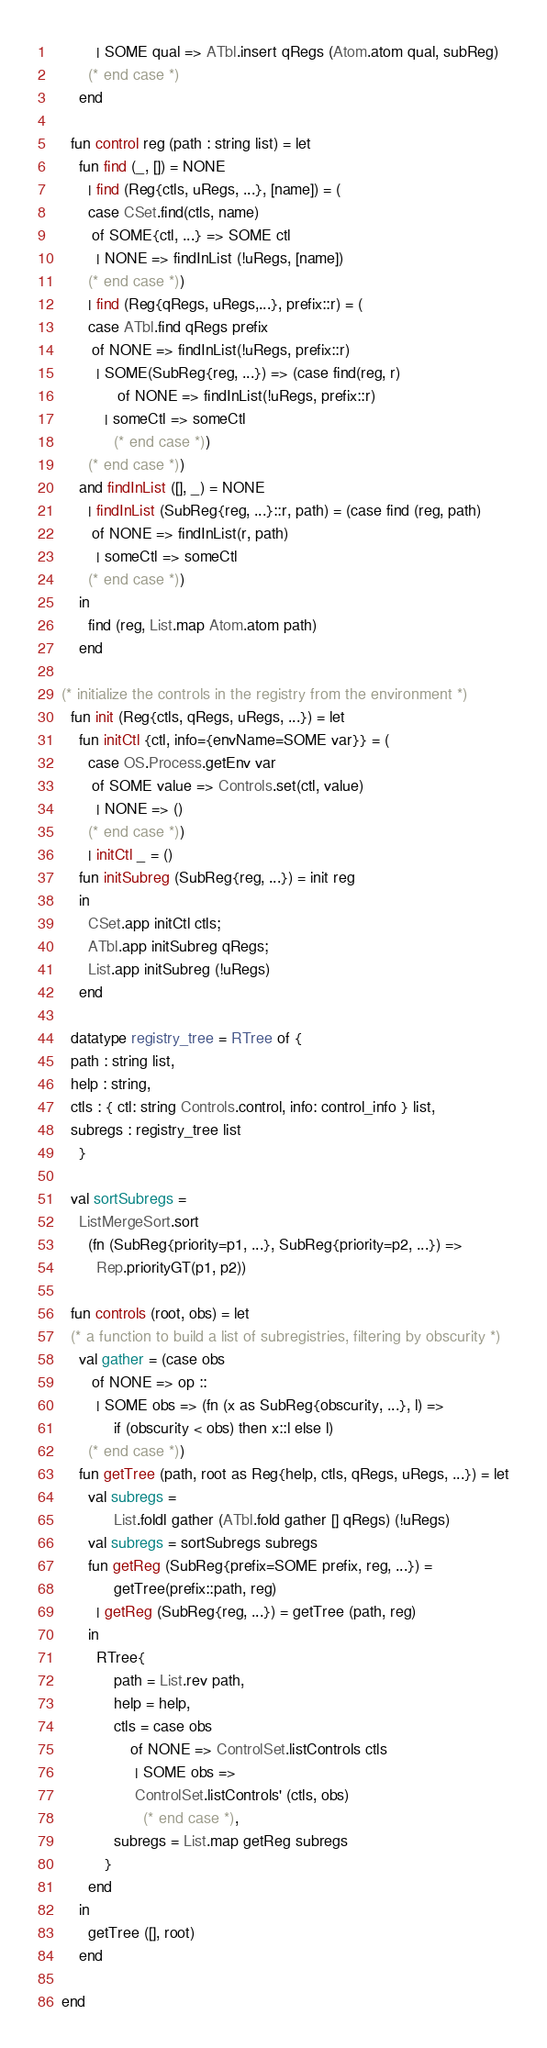<code> <loc_0><loc_0><loc_500><loc_500><_SML_>	      | SOME qual => ATbl.insert qRegs (Atom.atom qual, subReg)
	    (* end case *)
	  end

    fun control reg (path : string list) = let
	  fun find (_, []) = NONE
	    | find (Reg{ctls, uRegs, ...}, [name]) = (
		case CSet.find(ctls, name)
		 of SOME{ctl, ...} => SOME ctl
		  | NONE => findInList (!uRegs, [name])
		(* end case *))
	    | find (Reg{qRegs, uRegs,...}, prefix::r) = (
		case ATbl.find qRegs prefix
		 of NONE => findInList(!uRegs, prefix::r)
		  | SOME(SubReg{reg, ...}) => (case find(reg, r)
		       of NONE => findInList(!uRegs, prefix::r)
			| someCtl => someCtl
		      (* end case *))
		(* end case *))
	  and findInList ([], _) = NONE
	    | findInList (SubReg{reg, ...}::r, path) = (case find (reg, path)
		 of NONE => findInList(r, path)
		  | someCtl => someCtl
		(* end case *))
	  in
	    find (reg, List.map Atom.atom path)
	  end

  (* initialize the controls in the registry from the environment *)
    fun init (Reg{ctls, qRegs, uRegs, ...}) = let
	  fun initCtl {ctl, info={envName=SOME var}} = (
		case OS.Process.getEnv var
		 of SOME value => Controls.set(ctl, value)
		  | NONE => ()
		(* end case *))
	    | initCtl _ = ()
	  fun initSubreg (SubReg{reg, ...}) = init reg
	  in
	    CSet.app initCtl ctls;
	    ATbl.app initSubreg qRegs;
	    List.app initSubreg (!uRegs)
	  end

    datatype registry_tree = RTree of {
	path : string list,
	help : string,
	ctls : { ctl: string Controls.control, info: control_info } list,
	subregs : registry_tree list
      }

    val sortSubregs =
	  ListMergeSort.sort
	    (fn (SubReg{priority=p1, ...}, SubReg{priority=p2, ...}) =>
	      Rep.priorityGT(p1, p2))

    fun controls (root, obs) = let
	(* a function to build a list of subregistries, filtering by obscurity *)
	  val gather = (case obs
		 of NONE => op ::
		  | SOME obs => (fn (x as SubReg{obscurity, ...}, l) =>
		      if (obscurity < obs) then x::l else l)
		(* end case *))
	  fun getTree (path, root as Reg{help, ctls, qRegs, uRegs, ...}) = let
		val subregs =
		      List.foldl gather (ATbl.fold gather [] qRegs) (!uRegs)
		val subregs = sortSubregs subregs
		fun getReg (SubReg{prefix=SOME prefix, reg, ...}) =
		      getTree(prefix::path, reg)
		  | getReg (SubReg{reg, ...}) = getTree (path, reg)
		in
		  RTree{
		      path = List.rev path,
		      help = help,
		      ctls = case obs
			      of NONE => ControlSet.listControls ctls
			       | SOME obs =>
				   ControlSet.listControls' (ctls, obs)
		             (* end case *),
		      subregs = List.map getReg subregs
		    }
		end
	  in
	    getTree ([], root)
	  end

  end
</code> 